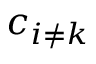<formula> <loc_0><loc_0><loc_500><loc_500>c _ { i \neq k }</formula> 